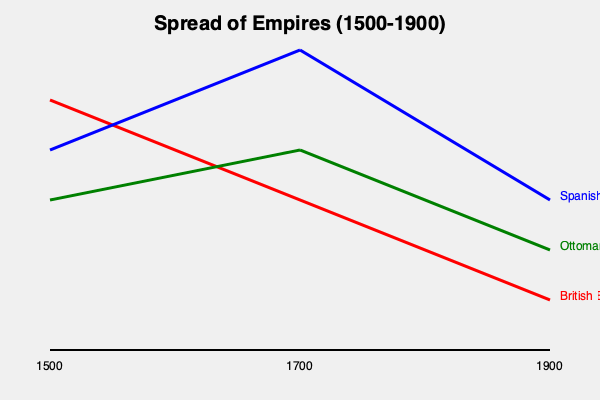Based on the graph showing the spread of empires from 1500 to 1900, which empire experienced the most significant expansion during this period, and what historical factors might explain this trend? To answer this question, we need to analyze the graph and consider historical context:

1. Observe the three empire lines: British (red), Spanish (blue), and Ottoman (green).

2. Compare the slopes of the lines:
   - British Empire: Starts low in 1500 and ends highest in 1900, showing steady growth.
   - Spanish Empire: Rapid growth from 1500 to 1700, then decline to 1900.
   - Ottoman Empire: Gradual growth from 1500 to 1700, then slight decline to 1900.

3. The British Empire line shows the most significant overall expansion, with the steepest positive slope throughout the period.

4. Historical factors explaining British expansion:
   a) Naval supremacy: British Royal Navy dominated the seas.
   b) Industrial Revolution: Began in Britain, providing technological and economic advantages.
   c) Colonial policies: Effective strategies for controlling and administering colonies.
   d) Trade networks: Establishment of global trade routes and the East India Company.

5. Comparison with other empires:
   - Spanish Empire: Initial rapid expansion due to New World colonization, but later decline due to overextension and competition.
   - Ottoman Empire: Gradual expansion in the early period, but later stagnation and decline due to military setbacks and internal challenges.

6. The British Empire's continuous growth contrasts with the other empires' patterns, indicating its dominance in this period.
Answer: British Empire; factors include naval supremacy, Industrial Revolution, effective colonial policies, and extensive trade networks. 